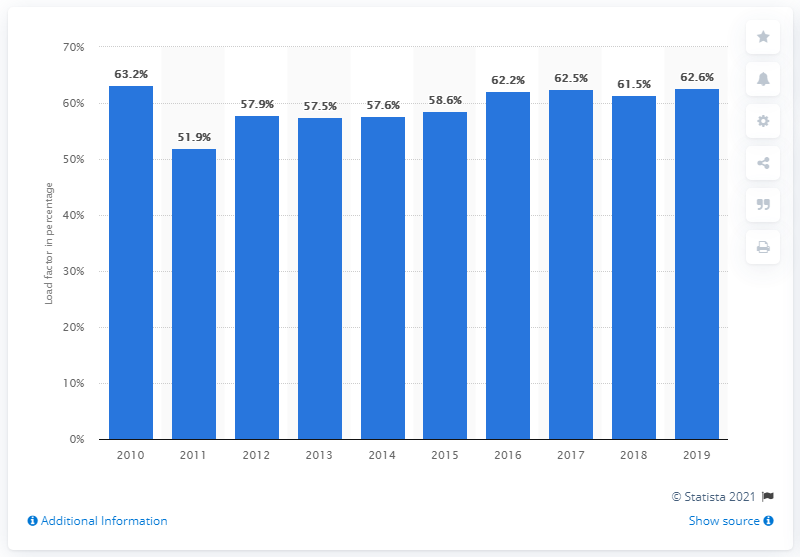Point out several critical features in this image. The load factor for electricity generation from anaerobic digestion in the UK began to fluctuate in 2010. The load factor of energy generated from anaerobic digestion in 2019 was 62.6%. 